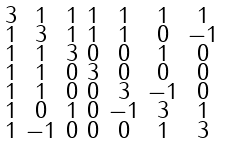Convert formula to latex. <formula><loc_0><loc_0><loc_500><loc_500>\begin{smallmatrix} 3 & 1 & 1 & 1 & 1 & 1 & 1 \\ 1 & 3 & 1 & 1 & 1 & 0 & - 1 \\ 1 & 1 & 3 & 0 & 0 & 1 & 0 \\ 1 & 1 & 0 & 3 & 0 & 0 & 0 \\ 1 & 1 & 0 & 0 & 3 & - 1 & 0 \\ 1 & 0 & 1 & 0 & - 1 & 3 & 1 \\ 1 & - 1 & 0 & 0 & 0 & 1 & 3 \end{smallmatrix}</formula> 